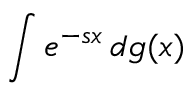Convert formula to latex. <formula><loc_0><loc_0><loc_500><loc_500>\int e ^ { - s x } \, d g ( x )</formula> 